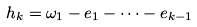Convert formula to latex. <formula><loc_0><loc_0><loc_500><loc_500>h _ { k } = \omega _ { 1 } - e _ { 1 } - \dots - e _ { k - 1 }</formula> 